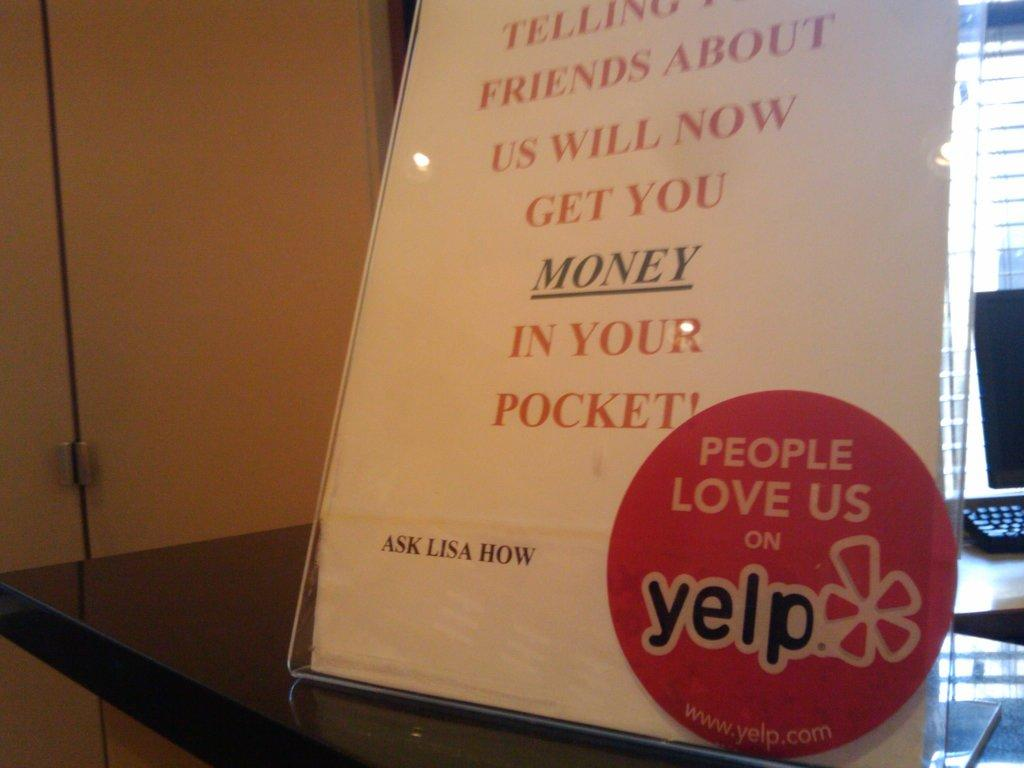<image>
Present a compact description of the photo's key features. A sign on a table has a sticker that says people love us on Yelp. 